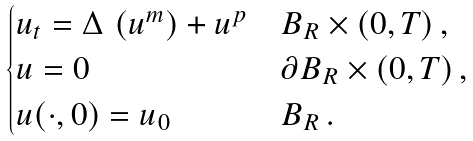Convert formula to latex. <formula><loc_0><loc_0><loc_500><loc_500>\begin{cases} u _ { t } = \Delta \, \left ( u ^ { m } \right ) + u ^ { p } & B _ { R } \times ( 0 , T ) \, , \\ u = 0 & \partial B _ { R } \times ( 0 , T ) \, , \\ u ( \cdot , 0 ) = u _ { 0 } & B _ { R } \, . \end{cases}</formula> 